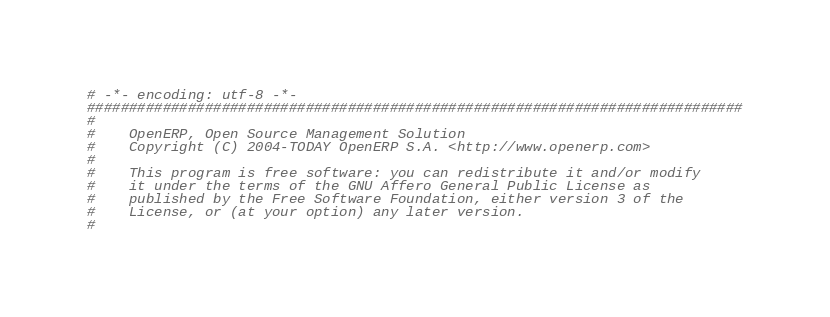Convert code to text. <code><loc_0><loc_0><loc_500><loc_500><_Python_># -*- encoding: utf-8 -*-
##############################################################################
#
#    OpenERP, Open Source Management Solution
#    Copyright (C) 2004-TODAY OpenERP S.A. <http://www.openerp.com>
#
#    This program is free software: you can redistribute it and/or modify
#    it under the terms of the GNU Affero General Public License as
#    published by the Free Software Foundation, either version 3 of the
#    License, or (at your option) any later version.
#</code> 